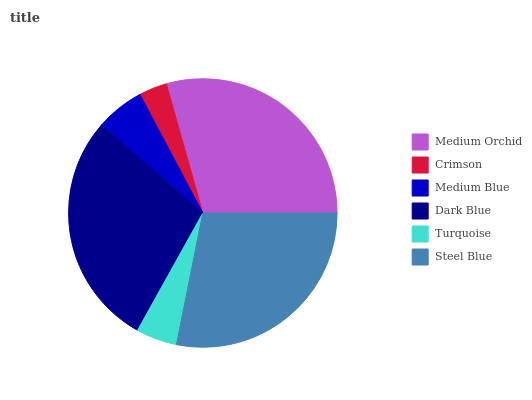Is Crimson the minimum?
Answer yes or no. Yes. Is Medium Orchid the maximum?
Answer yes or no. Yes. Is Medium Blue the minimum?
Answer yes or no. No. Is Medium Blue the maximum?
Answer yes or no. No. Is Medium Blue greater than Crimson?
Answer yes or no. Yes. Is Crimson less than Medium Blue?
Answer yes or no. Yes. Is Crimson greater than Medium Blue?
Answer yes or no. No. Is Medium Blue less than Crimson?
Answer yes or no. No. Is Steel Blue the high median?
Answer yes or no. Yes. Is Medium Blue the low median?
Answer yes or no. Yes. Is Medium Orchid the high median?
Answer yes or no. No. Is Dark Blue the low median?
Answer yes or no. No. 